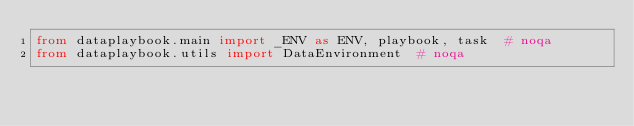Convert code to text. <code><loc_0><loc_0><loc_500><loc_500><_Python_>from dataplaybook.main import _ENV as ENV, playbook, task  # noqa
from dataplaybook.utils import DataEnvironment  # noqa
</code> 